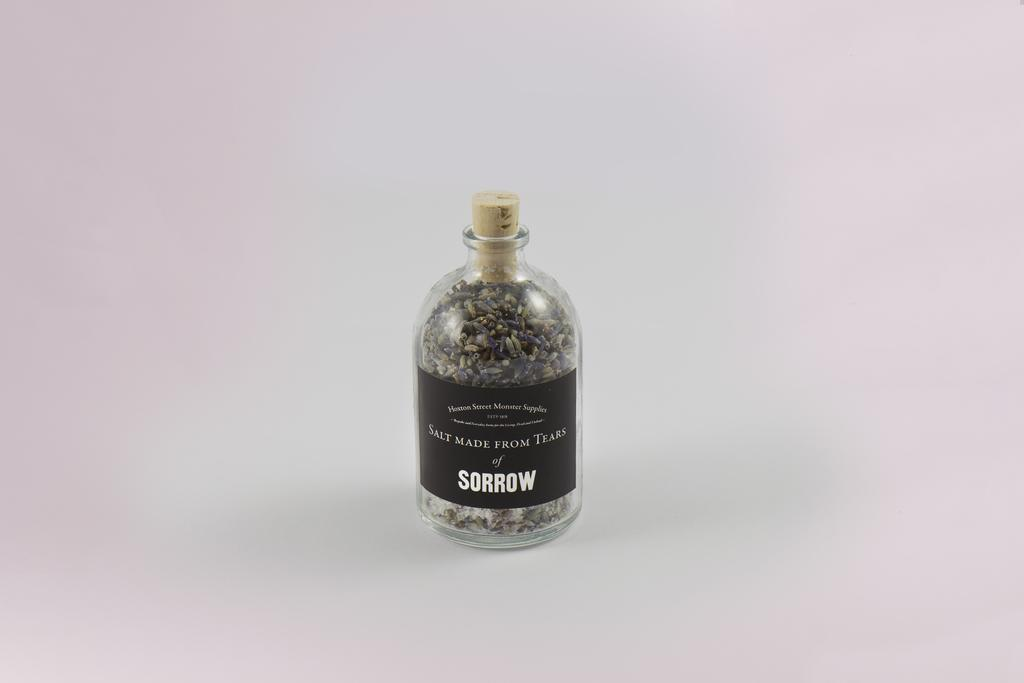<image>
Offer a succinct explanation of the picture presented. A bottle of salt made from tears of sorrow has a cork in it. 